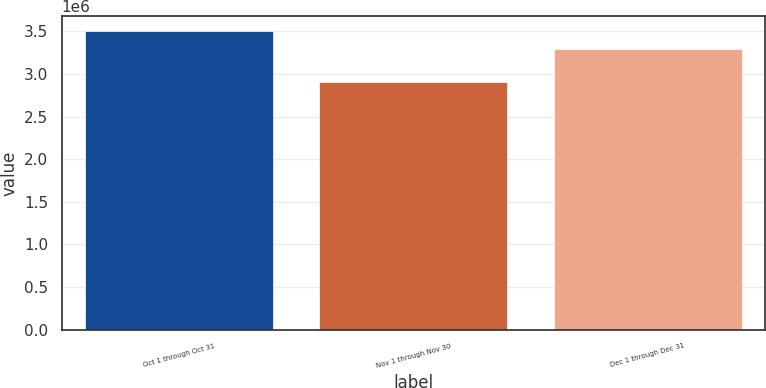Convert chart to OTSL. <chart><loc_0><loc_0><loc_500><loc_500><bar_chart><fcel>Oct 1 through Oct 31<fcel>Nov 1 through Nov 30<fcel>Dec 1 through Dec 31<nl><fcel>3.50131e+06<fcel>2.90117e+06<fcel>3.29665e+06<nl></chart> 